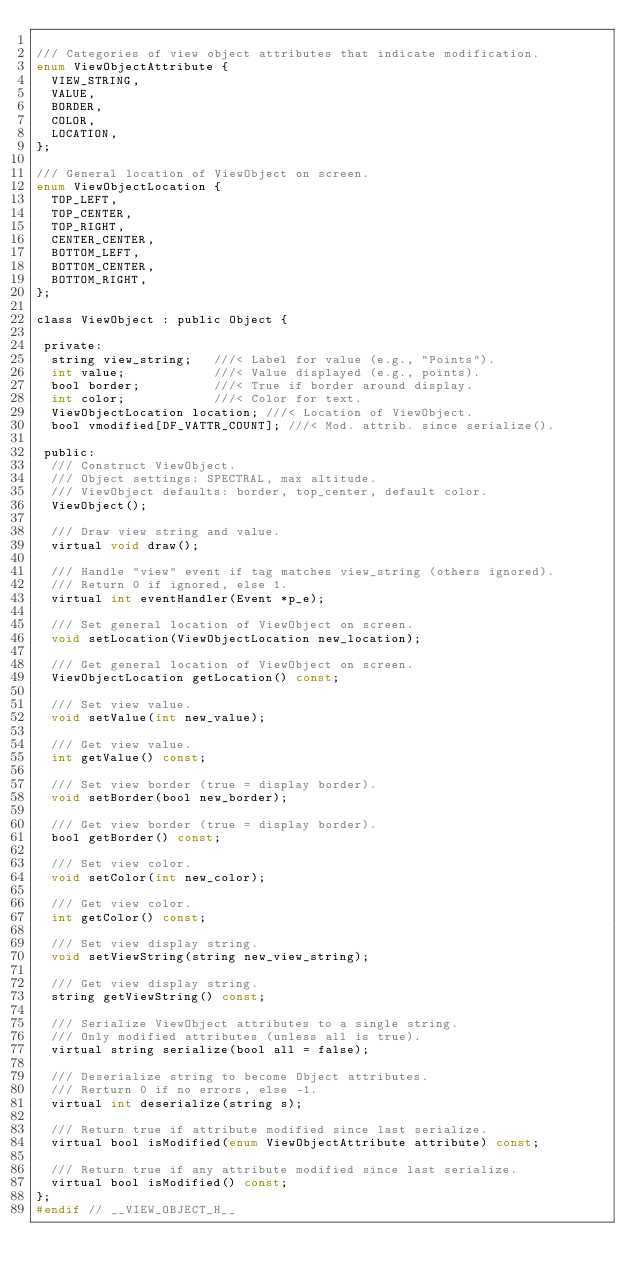Convert code to text. <code><loc_0><loc_0><loc_500><loc_500><_C_>
/// Categories of view object attributes that indicate modification.
enum ViewObjectAttribute {
  VIEW_STRING,
  VALUE,
  BORDER,
  COLOR,
  LOCATION,
};

/// General location of ViewObject on screen.
enum ViewObjectLocation {
  TOP_LEFT,
  TOP_CENTER,
  TOP_RIGHT,
  CENTER_CENTER,
  BOTTOM_LEFT,
  BOTTOM_CENTER,
  BOTTOM_RIGHT,
};

class ViewObject : public Object {

 private:
  string view_string;   ///< Label for value (e.g., "Points").
  int value;            ///< Value displayed (e.g., points).
  bool border;          ///< True if border around display.
  int color;            ///< Color for text.
  ViewObjectLocation location; ///< Location of ViewObject.
  bool vmodified[DF_VATTR_COUNT]; ///< Mod. attrib. since serialize().

 public:
  /// Construct ViewObject. 
  /// Object settings: SPECTRAL, max altitude.
  /// ViewObject defaults: border, top_center, default color.
  ViewObject();

  /// Draw view string and value.
  virtual void draw();

  /// Handle "view" event if tag matches view_string (others ignored).
  /// Return 0 if ignored, else 1.
  virtual int eventHandler(Event *p_e);

  /// Set general location of ViewObject on screen.
  void setLocation(ViewObjectLocation new_location);

  /// Get general location of ViewObject on screen.
  ViewObjectLocation getLocation() const;

  /// Set view value.
  void setValue(int new_value);

  /// Get view value.
  int getValue() const;

  /// Set view border (true = display border).
  void setBorder(bool new_border);

  /// Get view border (true = display border).
  bool getBorder() const;

  /// Set view color.
  void setColor(int new_color);

  /// Get view color.
  int getColor() const;

  /// Set view display string.
  void setViewString(string new_view_string);

  /// Get view display string.
  string getViewString() const;
  
  /// Serialize ViewObject attributes to a single string.
  /// Only modified attributes (unless all is true).
  virtual string serialize(bool all = false);

  /// Deserialize string to become Object attributes.
  /// Rerturn 0 if no errors, else -1.  
  virtual int deserialize(string s);

  /// Return true if attribute modified since last serialize.
  virtual bool isModified(enum ViewObjectAttribute attribute) const;
  
  /// Return true if any attribute modified since last serialize.
  virtual bool isModified() const;
};
#endif // __VIEW_OBJECT_H__
</code> 